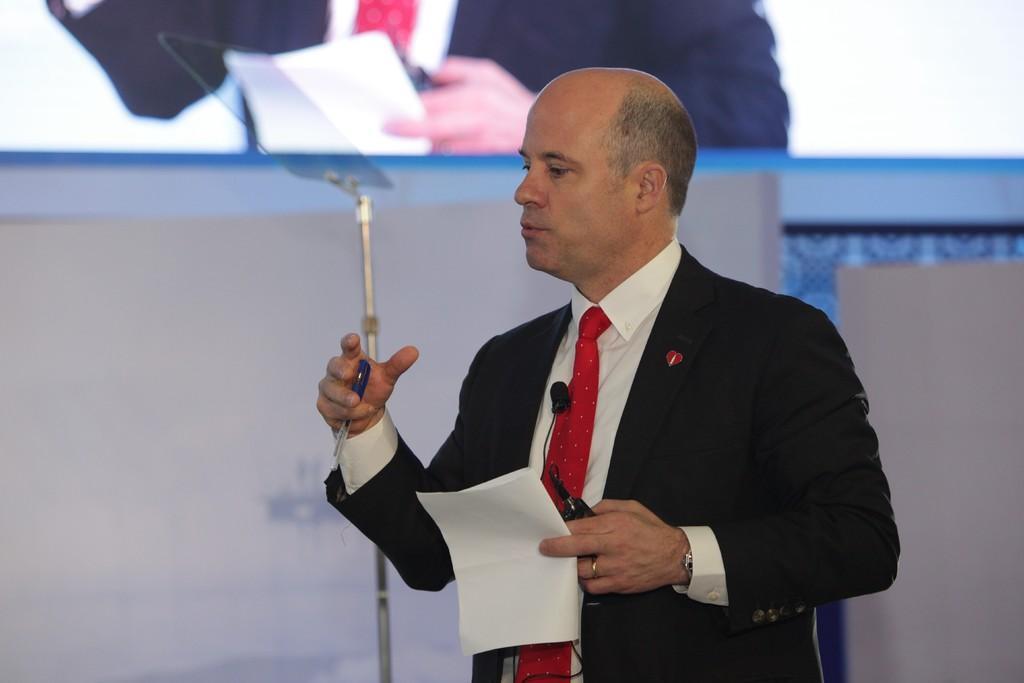How would you summarize this image in a sentence or two? A man is holding paper and pen, this is screen. 